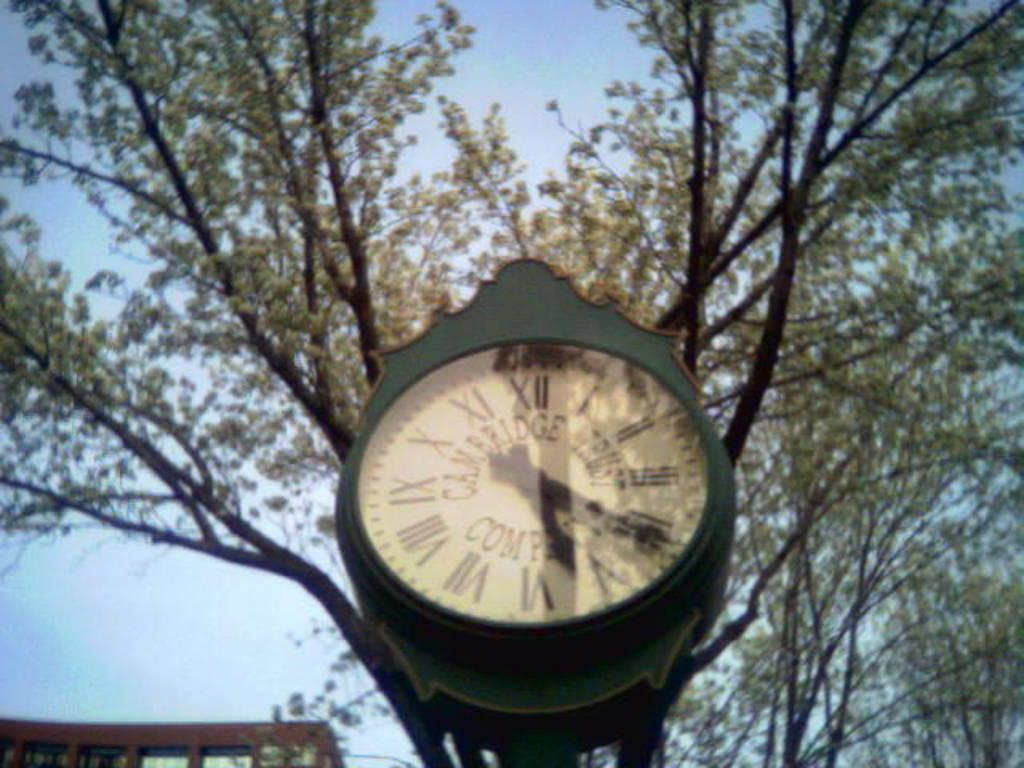<image>
Give a short and clear explanation of the subsequent image. a clock that shows five twenty two on it 